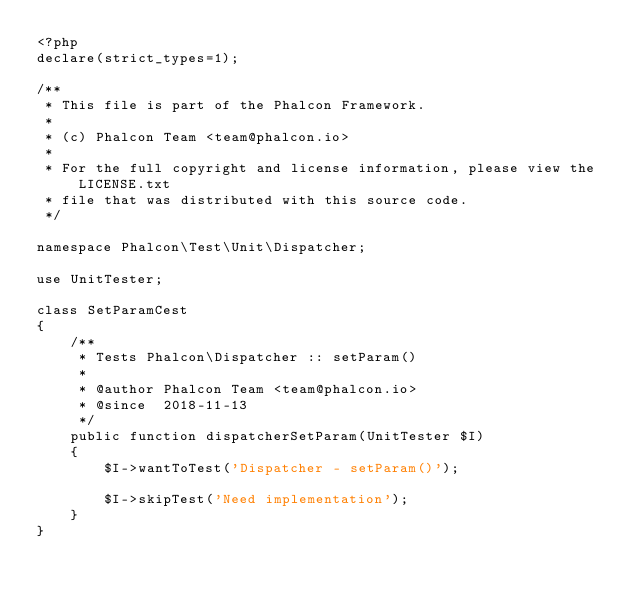Convert code to text. <code><loc_0><loc_0><loc_500><loc_500><_PHP_><?php
declare(strict_types=1);

/**
 * This file is part of the Phalcon Framework.
 *
 * (c) Phalcon Team <team@phalcon.io>
 *
 * For the full copyright and license information, please view the LICENSE.txt
 * file that was distributed with this source code.
 */

namespace Phalcon\Test\Unit\Dispatcher;

use UnitTester;

class SetParamCest
{
    /**
     * Tests Phalcon\Dispatcher :: setParam()
     *
     * @author Phalcon Team <team@phalcon.io>
     * @since  2018-11-13
     */
    public function dispatcherSetParam(UnitTester $I)
    {
        $I->wantToTest('Dispatcher - setParam()');

        $I->skipTest('Need implementation');
    }
}
</code> 